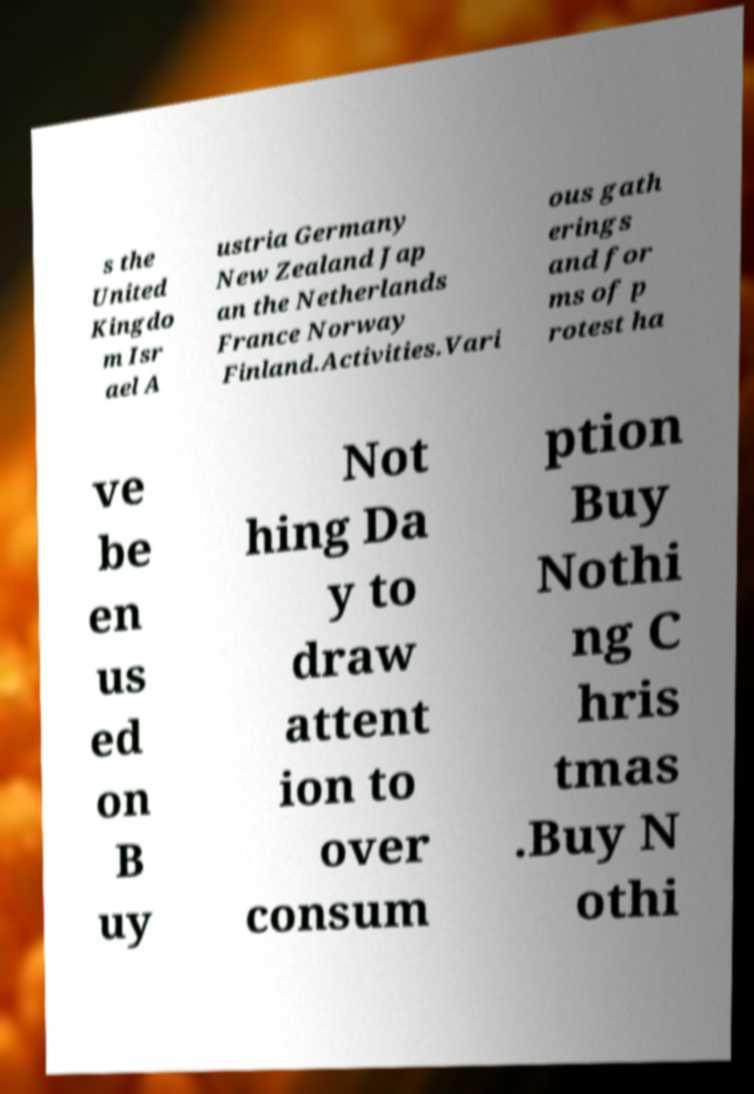Can you read and provide the text displayed in the image?This photo seems to have some interesting text. Can you extract and type it out for me? s the United Kingdo m Isr ael A ustria Germany New Zealand Jap an the Netherlands France Norway Finland.Activities.Vari ous gath erings and for ms of p rotest ha ve be en us ed on B uy Not hing Da y to draw attent ion to over consum ption Buy Nothi ng C hris tmas .Buy N othi 